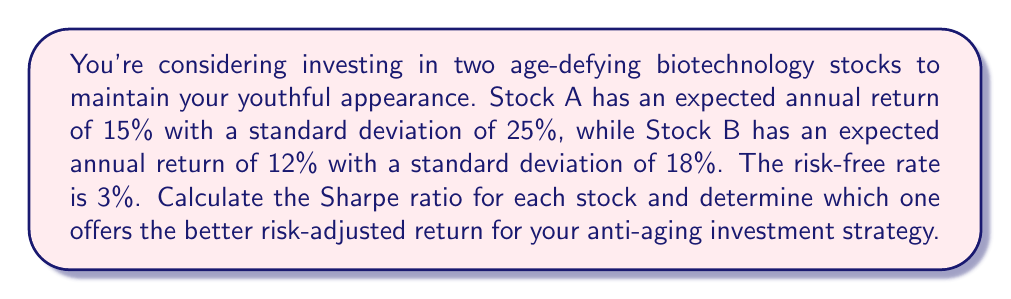Show me your answer to this math problem. To solve this problem, we'll use the Sharpe ratio, which measures the risk-adjusted return of an investment. The formula for the Sharpe ratio is:

$$ \text{Sharpe Ratio} = \frac{R_p - R_f}{\sigma_p} $$

Where:
$R_p$ = Expected return of the portfolio (or individual stock)
$R_f$ = Risk-free rate
$\sigma_p$ = Standard deviation of the portfolio (or individual stock)

Let's calculate the Sharpe ratio for each stock:

For Stock A:
$$ \text{Sharpe Ratio}_A = \frac{15\% - 3\%}{25\%} = \frac{12\%}{25\%} = 0.48 $$

For Stock B:
$$ \text{Sharpe Ratio}_B = \frac{12\% - 3\%}{18\%} = \frac{9\%}{18\%} = 0.50 $$

The higher the Sharpe ratio, the better the risk-adjusted return. In this case, Stock B has a slightly higher Sharpe ratio (0.50) compared to Stock A (0.48), indicating that it offers a better risk-adjusted return for your anti-aging investment strategy.

This means that for each unit of risk taken, Stock B provides a higher excess return over the risk-free rate compared to Stock A. While Stock A has a higher expected return (15% vs 12%), it also comes with higher volatility (25% vs 18%). The Sharpe ratio helps us balance these factors to make a more informed decision.
Answer: Stock B offers the better risk-adjusted return with a Sharpe ratio of 0.50, compared to Stock A's Sharpe ratio of 0.48. 